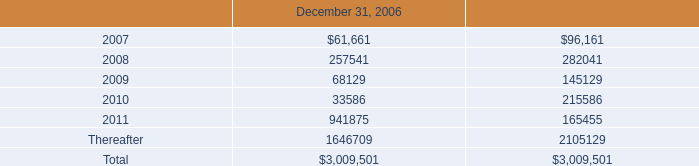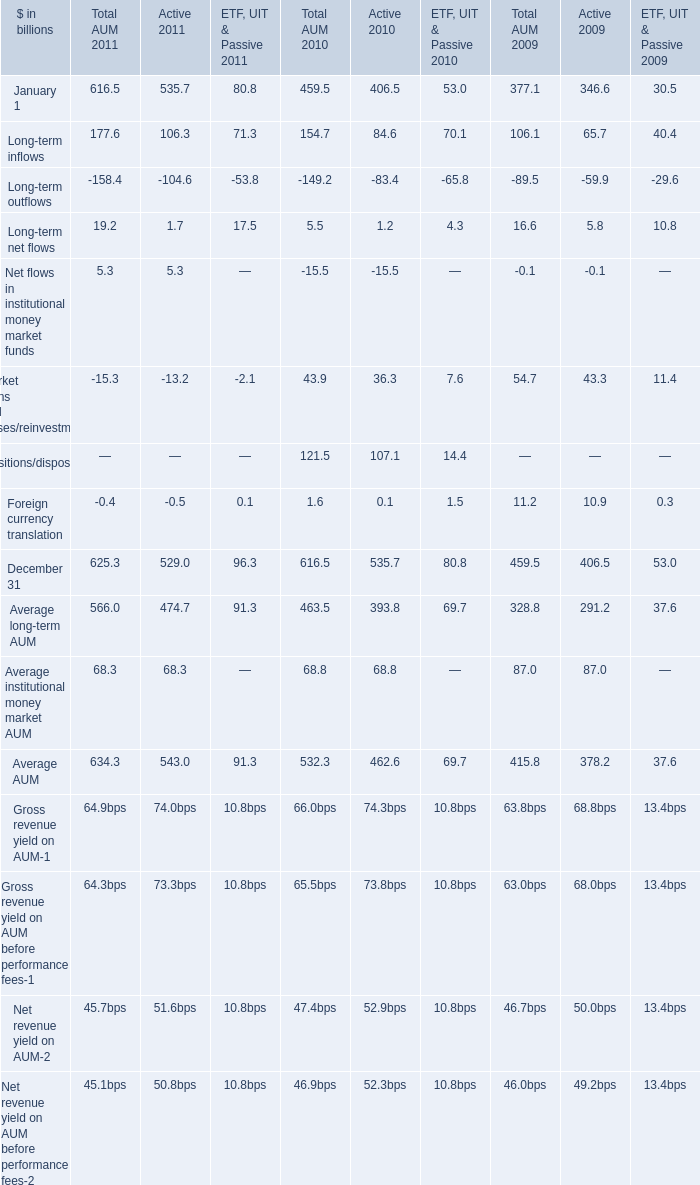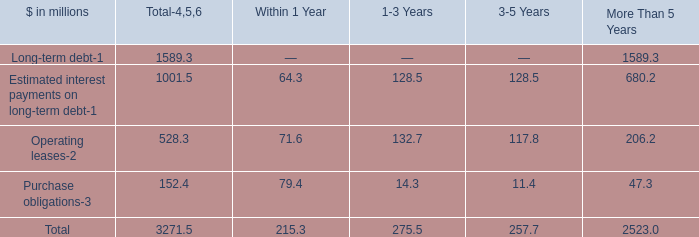Which year is Long-term net flows greater than 6? 
Answer: 2011. 